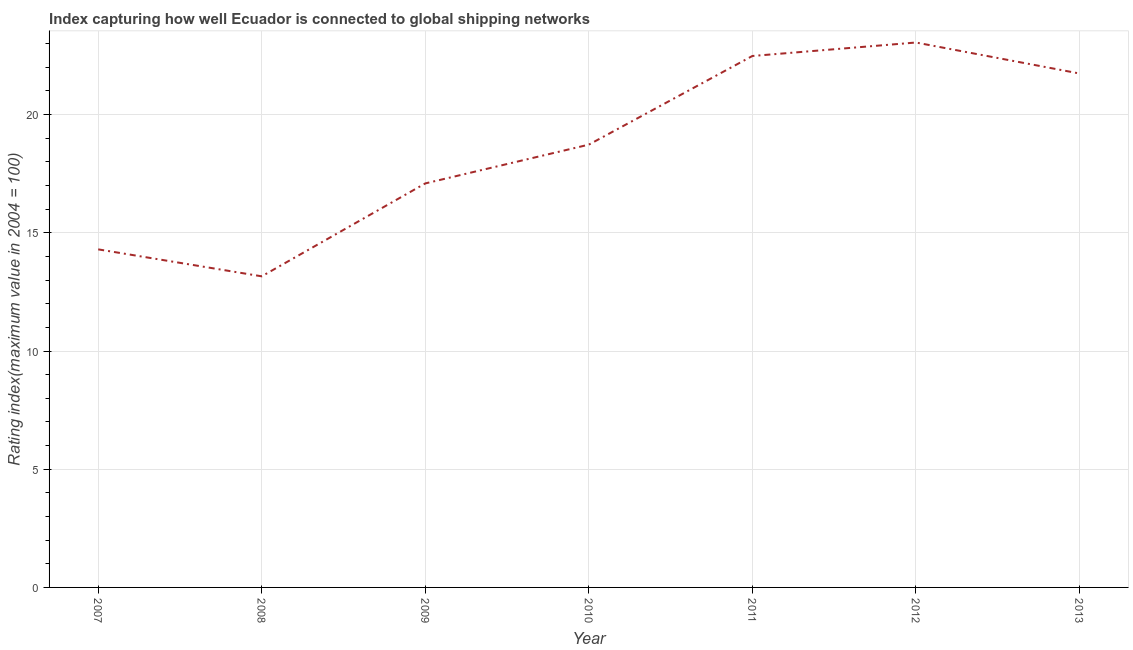What is the liner shipping connectivity index in 2008?
Keep it short and to the point. 13.16. Across all years, what is the maximum liner shipping connectivity index?
Keep it short and to the point. 23.05. Across all years, what is the minimum liner shipping connectivity index?
Make the answer very short. 13.16. In which year was the liner shipping connectivity index maximum?
Ensure brevity in your answer.  2012. In which year was the liner shipping connectivity index minimum?
Offer a terse response. 2008. What is the sum of the liner shipping connectivity index?
Ensure brevity in your answer.  130.55. What is the difference between the liner shipping connectivity index in 2012 and 2013?
Your answer should be very brief. 1.31. What is the average liner shipping connectivity index per year?
Your answer should be very brief. 18.65. What is the median liner shipping connectivity index?
Give a very brief answer. 18.73. In how many years, is the liner shipping connectivity index greater than 22 ?
Make the answer very short. 2. Do a majority of the years between 2013 and 2012 (inclusive) have liner shipping connectivity index greater than 19 ?
Your answer should be compact. No. What is the ratio of the liner shipping connectivity index in 2008 to that in 2009?
Your response must be concise. 0.77. Is the liner shipping connectivity index in 2009 less than that in 2010?
Your answer should be very brief. Yes. Is the difference between the liner shipping connectivity index in 2008 and 2010 greater than the difference between any two years?
Make the answer very short. No. What is the difference between the highest and the second highest liner shipping connectivity index?
Your answer should be very brief. 0.57. Is the sum of the liner shipping connectivity index in 2008 and 2012 greater than the maximum liner shipping connectivity index across all years?
Your answer should be very brief. Yes. What is the difference between the highest and the lowest liner shipping connectivity index?
Keep it short and to the point. 9.89. In how many years, is the liner shipping connectivity index greater than the average liner shipping connectivity index taken over all years?
Offer a terse response. 4. Does the liner shipping connectivity index monotonically increase over the years?
Ensure brevity in your answer.  No. How many lines are there?
Provide a succinct answer. 1. How many years are there in the graph?
Give a very brief answer. 7. What is the difference between two consecutive major ticks on the Y-axis?
Make the answer very short. 5. Does the graph contain any zero values?
Your response must be concise. No. What is the title of the graph?
Keep it short and to the point. Index capturing how well Ecuador is connected to global shipping networks. What is the label or title of the X-axis?
Ensure brevity in your answer.  Year. What is the label or title of the Y-axis?
Make the answer very short. Rating index(maximum value in 2004 = 100). What is the Rating index(maximum value in 2004 = 100) of 2007?
Provide a short and direct response. 14.3. What is the Rating index(maximum value in 2004 = 100) of 2008?
Offer a very short reply. 13.16. What is the Rating index(maximum value in 2004 = 100) in 2009?
Offer a terse response. 17.09. What is the Rating index(maximum value in 2004 = 100) in 2010?
Your answer should be compact. 18.73. What is the Rating index(maximum value in 2004 = 100) in 2011?
Offer a terse response. 22.48. What is the Rating index(maximum value in 2004 = 100) of 2012?
Your answer should be compact. 23.05. What is the Rating index(maximum value in 2004 = 100) of 2013?
Give a very brief answer. 21.74. What is the difference between the Rating index(maximum value in 2004 = 100) in 2007 and 2008?
Your response must be concise. 1.14. What is the difference between the Rating index(maximum value in 2004 = 100) in 2007 and 2009?
Your response must be concise. -2.79. What is the difference between the Rating index(maximum value in 2004 = 100) in 2007 and 2010?
Your answer should be compact. -4.43. What is the difference between the Rating index(maximum value in 2004 = 100) in 2007 and 2011?
Your response must be concise. -8.18. What is the difference between the Rating index(maximum value in 2004 = 100) in 2007 and 2012?
Make the answer very short. -8.75. What is the difference between the Rating index(maximum value in 2004 = 100) in 2007 and 2013?
Provide a succinct answer. -7.44. What is the difference between the Rating index(maximum value in 2004 = 100) in 2008 and 2009?
Your response must be concise. -3.93. What is the difference between the Rating index(maximum value in 2004 = 100) in 2008 and 2010?
Ensure brevity in your answer.  -5.57. What is the difference between the Rating index(maximum value in 2004 = 100) in 2008 and 2011?
Offer a terse response. -9.32. What is the difference between the Rating index(maximum value in 2004 = 100) in 2008 and 2012?
Offer a very short reply. -9.89. What is the difference between the Rating index(maximum value in 2004 = 100) in 2008 and 2013?
Your answer should be compact. -8.58. What is the difference between the Rating index(maximum value in 2004 = 100) in 2009 and 2010?
Your response must be concise. -1.64. What is the difference between the Rating index(maximum value in 2004 = 100) in 2009 and 2011?
Your response must be concise. -5.39. What is the difference between the Rating index(maximum value in 2004 = 100) in 2009 and 2012?
Your answer should be compact. -5.96. What is the difference between the Rating index(maximum value in 2004 = 100) in 2009 and 2013?
Keep it short and to the point. -4.65. What is the difference between the Rating index(maximum value in 2004 = 100) in 2010 and 2011?
Make the answer very short. -3.75. What is the difference between the Rating index(maximum value in 2004 = 100) in 2010 and 2012?
Your response must be concise. -4.32. What is the difference between the Rating index(maximum value in 2004 = 100) in 2010 and 2013?
Your response must be concise. -3.01. What is the difference between the Rating index(maximum value in 2004 = 100) in 2011 and 2012?
Offer a very short reply. -0.57. What is the difference between the Rating index(maximum value in 2004 = 100) in 2011 and 2013?
Ensure brevity in your answer.  0.74. What is the difference between the Rating index(maximum value in 2004 = 100) in 2012 and 2013?
Offer a terse response. 1.31. What is the ratio of the Rating index(maximum value in 2004 = 100) in 2007 to that in 2008?
Make the answer very short. 1.09. What is the ratio of the Rating index(maximum value in 2004 = 100) in 2007 to that in 2009?
Make the answer very short. 0.84. What is the ratio of the Rating index(maximum value in 2004 = 100) in 2007 to that in 2010?
Make the answer very short. 0.76. What is the ratio of the Rating index(maximum value in 2004 = 100) in 2007 to that in 2011?
Ensure brevity in your answer.  0.64. What is the ratio of the Rating index(maximum value in 2004 = 100) in 2007 to that in 2012?
Ensure brevity in your answer.  0.62. What is the ratio of the Rating index(maximum value in 2004 = 100) in 2007 to that in 2013?
Offer a terse response. 0.66. What is the ratio of the Rating index(maximum value in 2004 = 100) in 2008 to that in 2009?
Give a very brief answer. 0.77. What is the ratio of the Rating index(maximum value in 2004 = 100) in 2008 to that in 2010?
Provide a short and direct response. 0.7. What is the ratio of the Rating index(maximum value in 2004 = 100) in 2008 to that in 2011?
Keep it short and to the point. 0.58. What is the ratio of the Rating index(maximum value in 2004 = 100) in 2008 to that in 2012?
Keep it short and to the point. 0.57. What is the ratio of the Rating index(maximum value in 2004 = 100) in 2008 to that in 2013?
Offer a terse response. 0.6. What is the ratio of the Rating index(maximum value in 2004 = 100) in 2009 to that in 2010?
Offer a very short reply. 0.91. What is the ratio of the Rating index(maximum value in 2004 = 100) in 2009 to that in 2011?
Keep it short and to the point. 0.76. What is the ratio of the Rating index(maximum value in 2004 = 100) in 2009 to that in 2012?
Keep it short and to the point. 0.74. What is the ratio of the Rating index(maximum value in 2004 = 100) in 2009 to that in 2013?
Keep it short and to the point. 0.79. What is the ratio of the Rating index(maximum value in 2004 = 100) in 2010 to that in 2011?
Keep it short and to the point. 0.83. What is the ratio of the Rating index(maximum value in 2004 = 100) in 2010 to that in 2012?
Your response must be concise. 0.81. What is the ratio of the Rating index(maximum value in 2004 = 100) in 2010 to that in 2013?
Offer a terse response. 0.86. What is the ratio of the Rating index(maximum value in 2004 = 100) in 2011 to that in 2013?
Ensure brevity in your answer.  1.03. What is the ratio of the Rating index(maximum value in 2004 = 100) in 2012 to that in 2013?
Offer a very short reply. 1.06. 